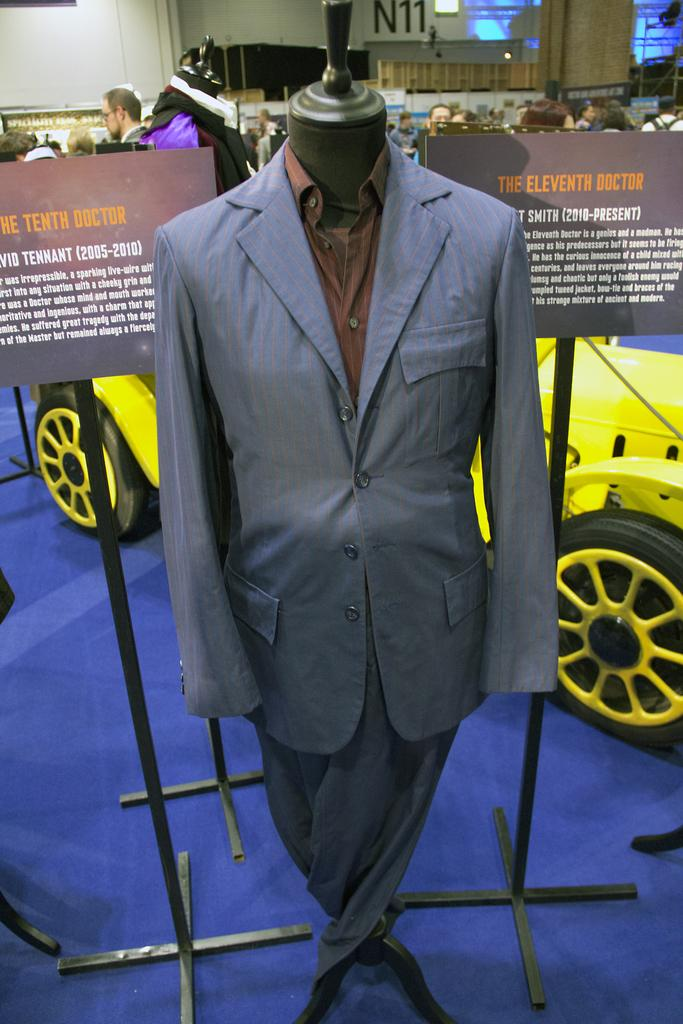What is displayed on the mannequin in the image? There are clothes on a mannequin in the image. What objects can be seen in the image besides the mannequin? There are boards, stands, a vehicle, and people in the background in the image. What is present in the background of the image? In the background of the image, there is a wall, boards, and lights. What type of pizzas are being served from the beam in the image? There is no beam or pizzas present in the image. How does the snow affect the visibility of the wall in the image? There is no snow present in the image, so it does not affect the visibility of the wall. 